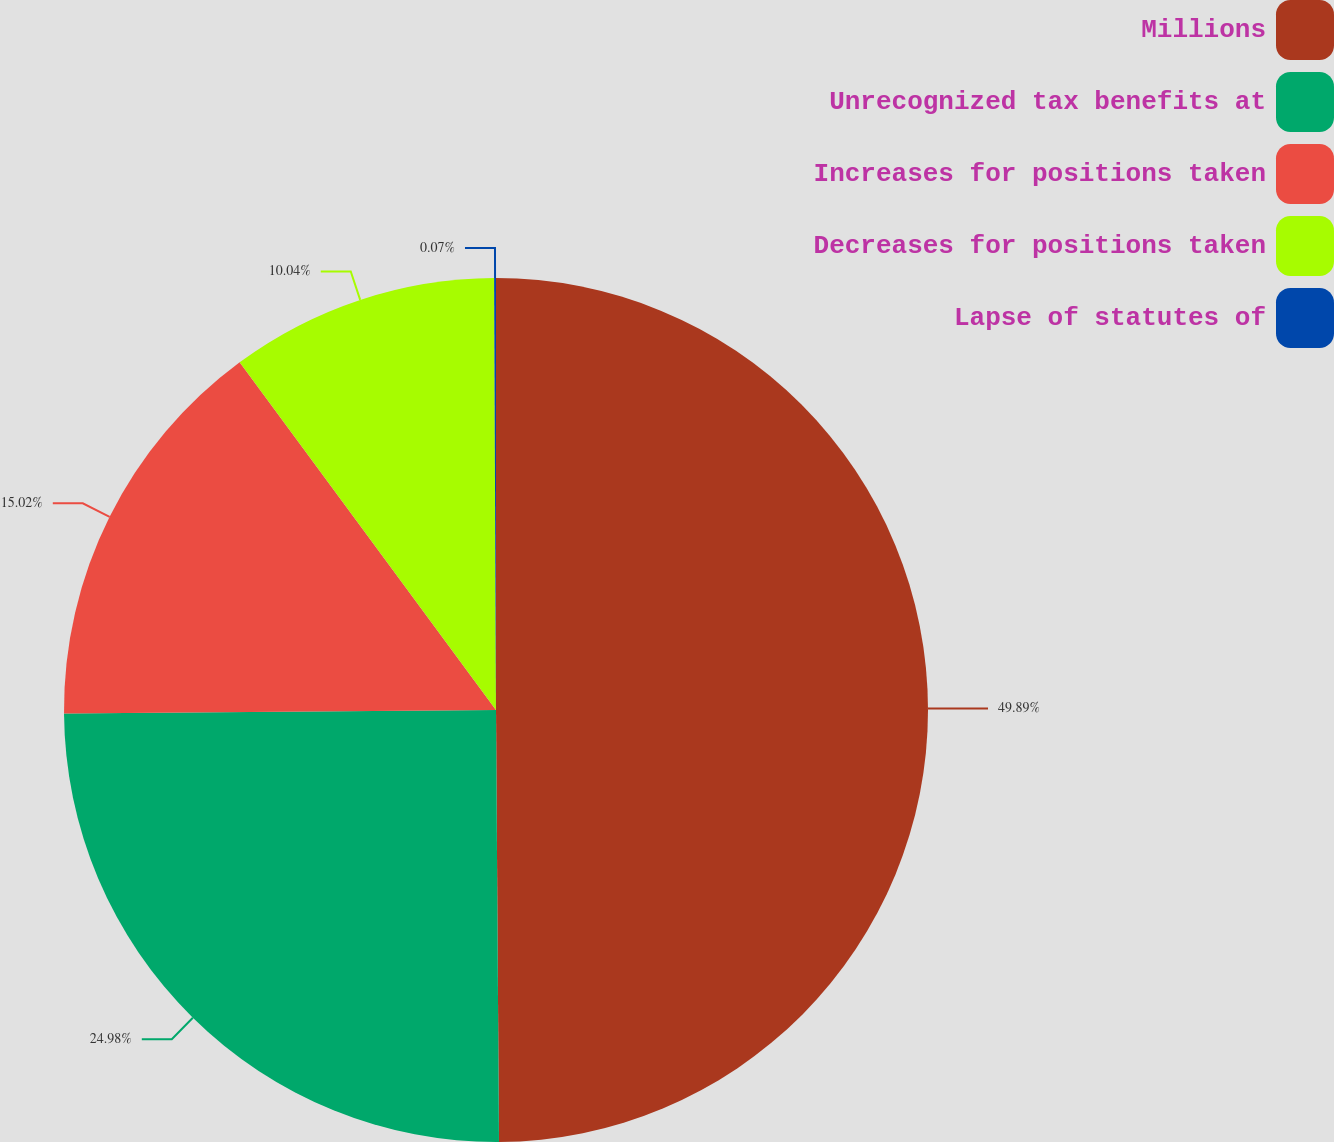Convert chart to OTSL. <chart><loc_0><loc_0><loc_500><loc_500><pie_chart><fcel>Millions<fcel>Unrecognized tax benefits at<fcel>Increases for positions taken<fcel>Decreases for positions taken<fcel>Lapse of statutes of<nl><fcel>49.89%<fcel>24.98%<fcel>15.02%<fcel>10.04%<fcel>0.07%<nl></chart> 